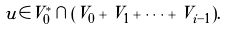Convert formula to latex. <formula><loc_0><loc_0><loc_500><loc_500>u \in V ^ { * } _ { 0 } \cap ( V _ { 0 } + V _ { 1 } + \cdots + V _ { i - 1 } ) .</formula> 